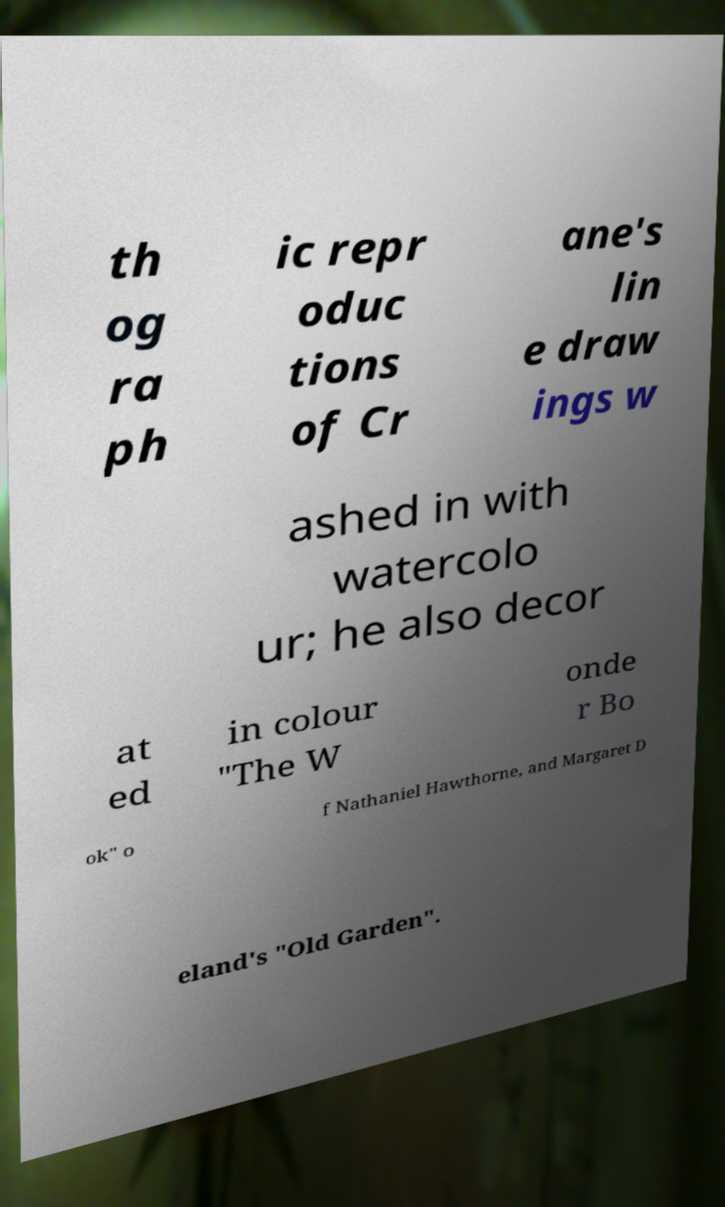There's text embedded in this image that I need extracted. Can you transcribe it verbatim? th og ra ph ic repr oduc tions of Cr ane's lin e draw ings w ashed in with watercolo ur; he also decor at ed in colour "The W onde r Bo ok" o f Nathaniel Hawthorne, and Margaret D eland's "Old Garden". 